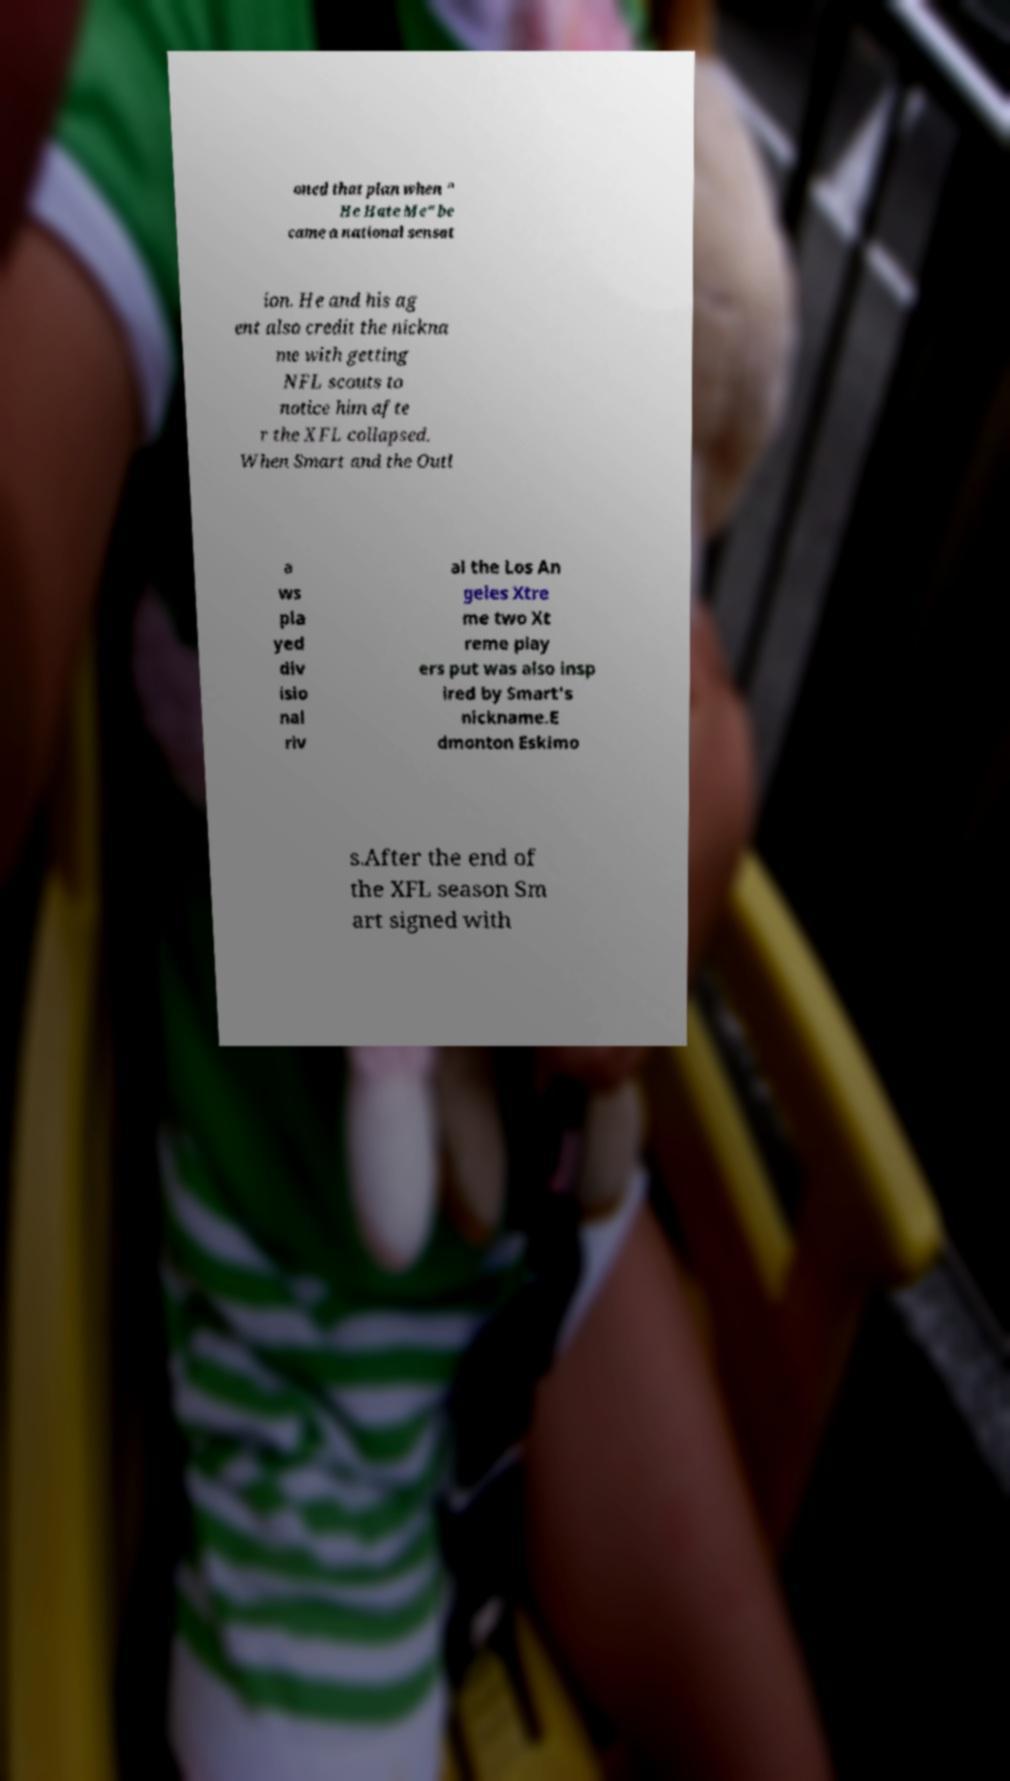There's text embedded in this image that I need extracted. Can you transcribe it verbatim? oned that plan when " He Hate Me" be came a national sensat ion. He and his ag ent also credit the nickna me with getting NFL scouts to notice him afte r the XFL collapsed. When Smart and the Outl a ws pla yed div isio nal riv al the Los An geles Xtre me two Xt reme play ers put was also insp ired by Smart's nickname.E dmonton Eskimo s.After the end of the XFL season Sm art signed with 